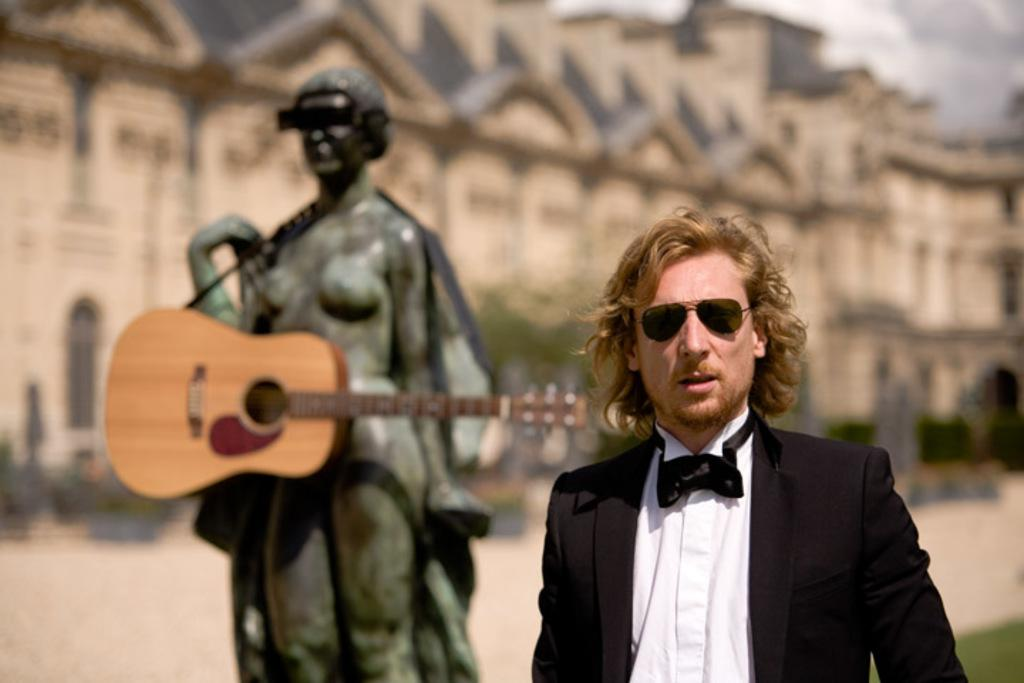What is the main subject of the image? There is a man in the image. What is the man wearing? The man is wearing a blazer and goggles. What can be seen in the image besides the man? There is a statue in the image, and it is holding a guitar. What is visible in the background of the image? There is a building and trees in the background of the image, and the background is blurred. What type of snail can be seen crawling on the guitar in the image? There is no snail present in the image, and therefore no such activity can be observed. What is the condition of the man's health in the image? The image does not provide any information about the man's health, so it cannot be determined from the image. 